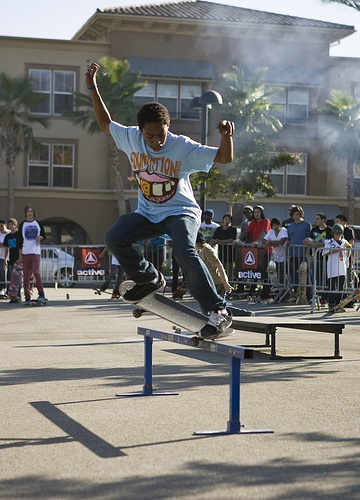Describe the objects in this image and their specific colors. I can see people in lavender, black, gray, and maroon tones, skateboard in lavender, gray, black, and darkgray tones, people in lavender, black, gray, and darkgray tones, people in lavender, black, darkgray, and gray tones, and car in lavender, gray, darkgray, and black tones in this image. 